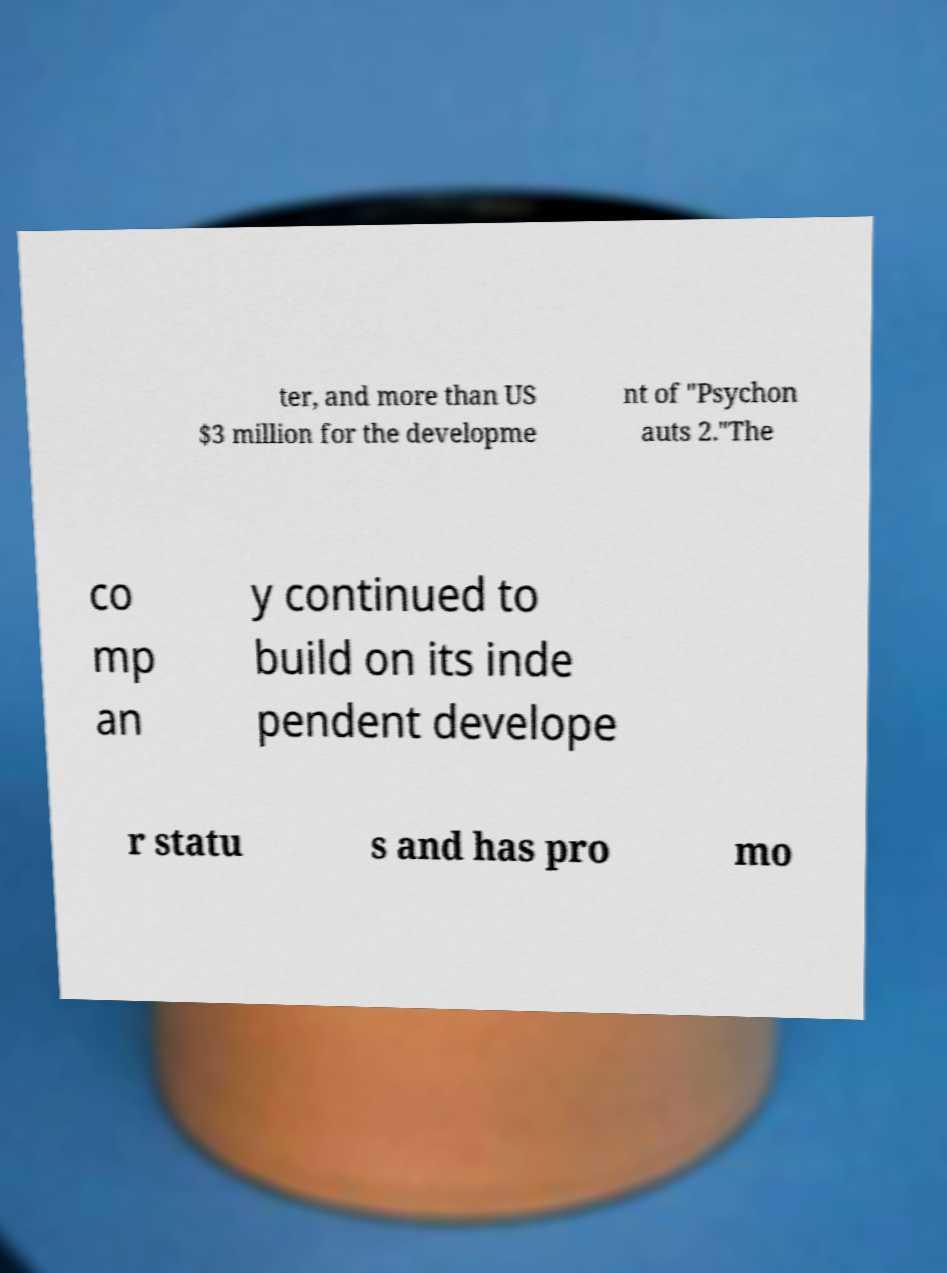What messages or text are displayed in this image? I need them in a readable, typed format. ter, and more than US $3 million for the developme nt of "Psychon auts 2."The co mp an y continued to build on its inde pendent develope r statu s and has pro mo 